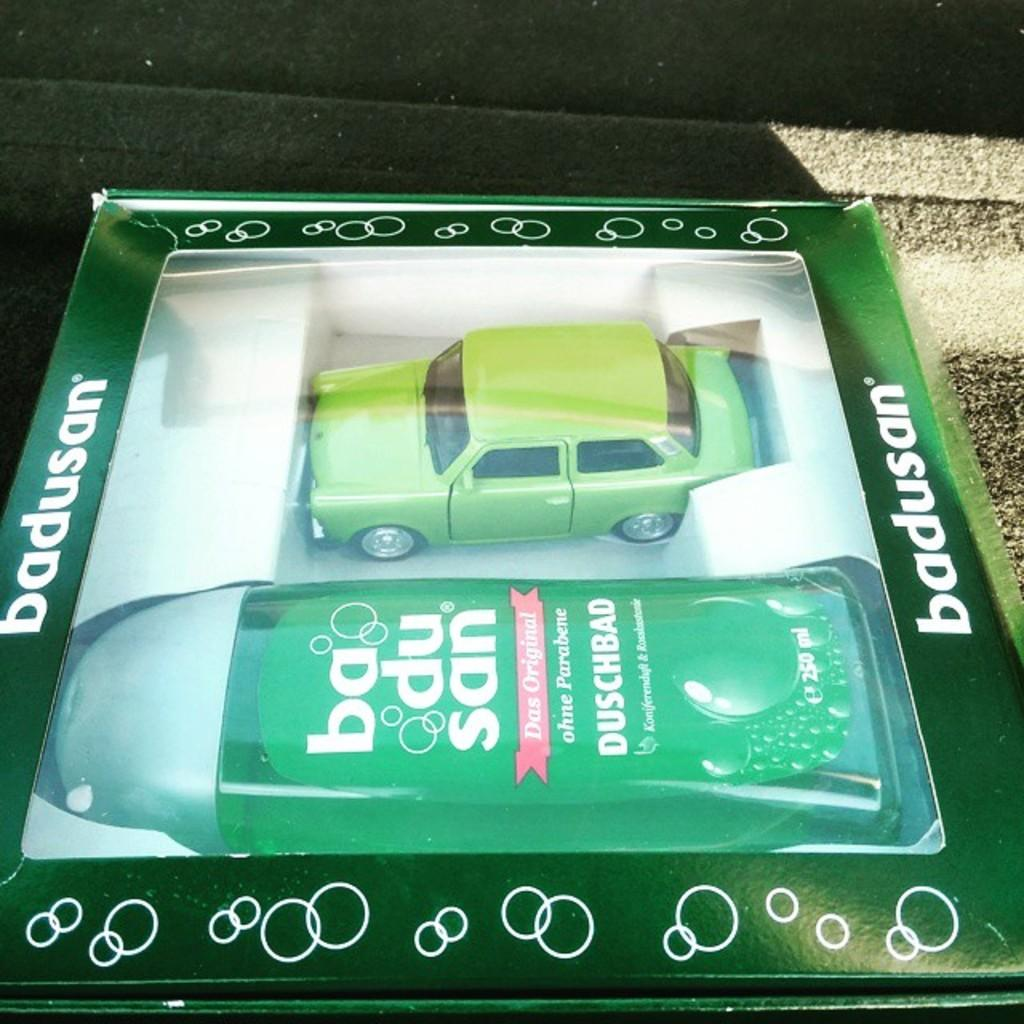What type of toy is present in the image? There is a toy car in the image. What other object can be seen in the image? There is a bottle in the image. Where are the toy car and the bottle located? Both the toy car and the bottle are in a box. What type of tent is visible in the image? There is no tent present in the image. How many shoes can be seen in the image? There are no shoes present in the image. 